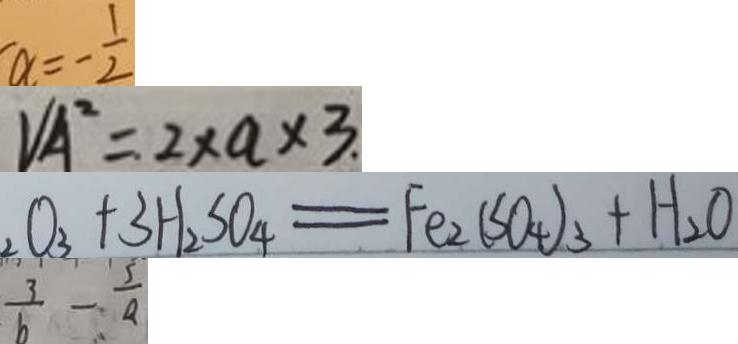Convert formula to latex. <formula><loc_0><loc_0><loc_500><loc_500>a = - \frac { 1 } { 2 } 
 V _ { A ^ { 2 } } = 2 \times a \times 3 . 
 O _ { 3 } + 3 H _ { 2 } S O _ { 4 } = F e _ { 2 } ( S O _ { 4 } ) _ { 3 } + H _ { 2 } O 
 \frac { 3 } { b } - \frac { 5 } { a }</formula> 